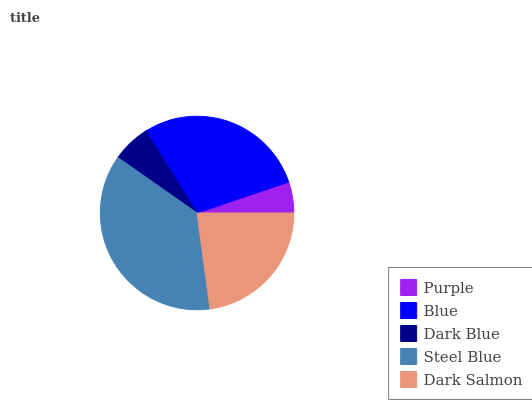Is Purple the minimum?
Answer yes or no. Yes. Is Steel Blue the maximum?
Answer yes or no. Yes. Is Blue the minimum?
Answer yes or no. No. Is Blue the maximum?
Answer yes or no. No. Is Blue greater than Purple?
Answer yes or no. Yes. Is Purple less than Blue?
Answer yes or no. Yes. Is Purple greater than Blue?
Answer yes or no. No. Is Blue less than Purple?
Answer yes or no. No. Is Dark Salmon the high median?
Answer yes or no. Yes. Is Dark Salmon the low median?
Answer yes or no. Yes. Is Steel Blue the high median?
Answer yes or no. No. Is Steel Blue the low median?
Answer yes or no. No. 